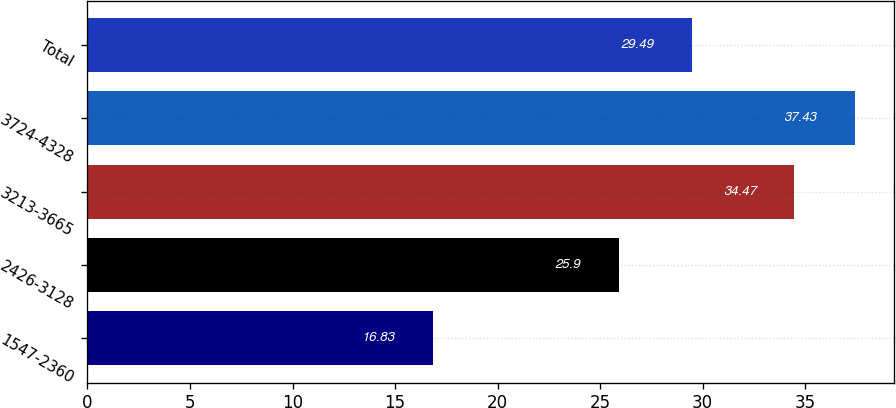Convert chart. <chart><loc_0><loc_0><loc_500><loc_500><bar_chart><fcel>1547-2360<fcel>2426-3128<fcel>3213-3665<fcel>3724-4328<fcel>Total<nl><fcel>16.83<fcel>25.9<fcel>34.47<fcel>37.43<fcel>29.49<nl></chart> 